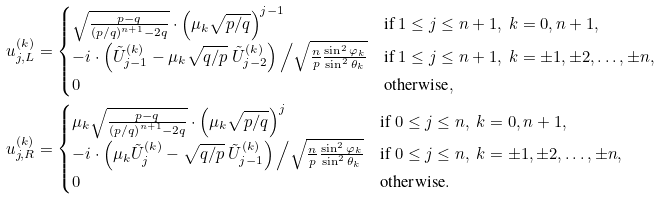<formula> <loc_0><loc_0><loc_500><loc_500>u _ { j , L } ^ { ( k ) } & = \begin{cases} \sqrt { \frac { p - q } { \left ( p / q \right ) ^ { n + 1 } - 2 q } } \cdot \left ( \mu _ { k } \sqrt { p / q } \right ) ^ { j - 1 } & \text {if\ $1\leq j\leq n+1,\ k=0, n+1$} , \\ - i \cdot \left ( \tilde { U } _ { j - 1 } ^ { ( k ) } - \mu _ { k } \sqrt { q / p } \ \tilde { U } _ { j - 2 } ^ { ( k ) } \right ) \Big / \sqrt { \frac { n } { p } \frac { \sin ^ { 2 } \varphi _ { k } } { \sin ^ { 2 } \theta _ { k } } } & \text {if\ $1\leq j\leq n+1,\ k=\pm 1,\pm 2,\dots, \pm n$} , \\ 0 & \text {otherwise} , \end{cases} \\ u _ { j , R } ^ { ( k ) } & = \begin{cases} \mu _ { k } \sqrt { \frac { p - q } { \left ( p / q \right ) ^ { n + 1 } - 2 q } } \cdot \left ( \mu _ { k } \sqrt { p / q } \right ) ^ { j } & \text {if\ $0\leq j\leq n,\ k=0, n+1$} , \\ - i \cdot \left ( \mu _ { k } \tilde { U } _ { j } ^ { ( k ) } - \sqrt { q / p } \ \tilde { U } _ { j - 1 } ^ { ( k ) } \right ) \Big / \sqrt { \frac { n } { p } \frac { \sin ^ { 2 } \varphi _ { k } } { \sin ^ { 2 } \theta _ { k } } } & \text {if\ $0\leq j\leq n,\ k=\pm 1,\pm 2,\dots, \pm n$} , \\ 0 & \text {otherwise} . \end{cases}</formula> 